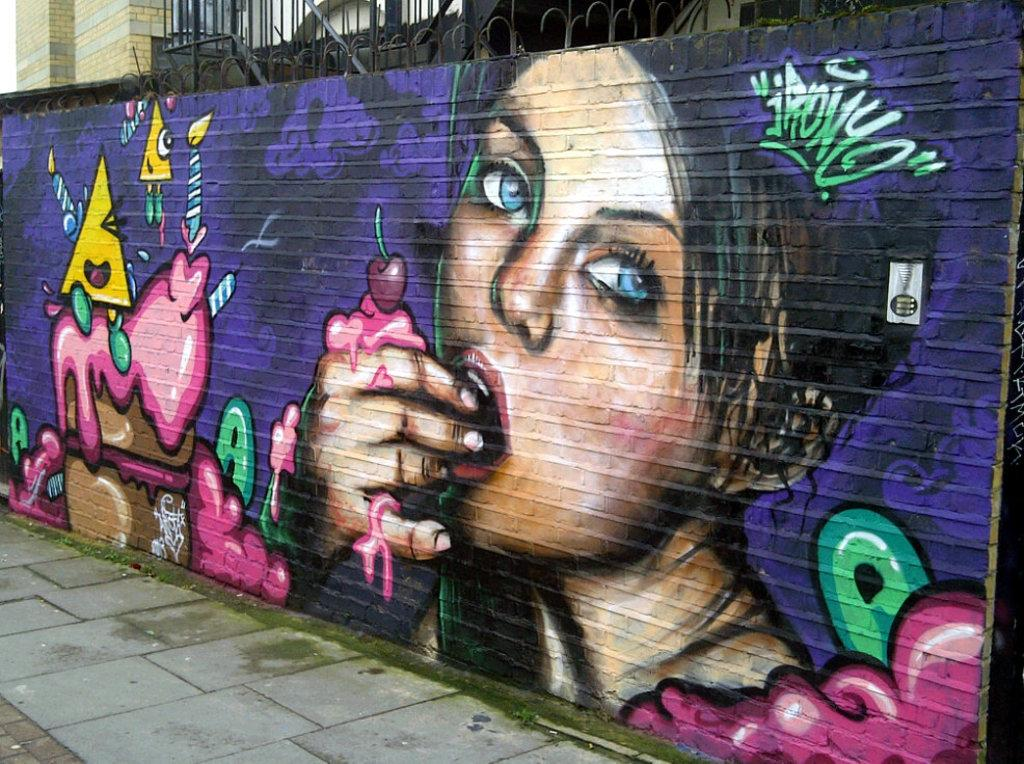What is located at the front of the image? There is a wall in the front of the image. What can be seen in the background of the image? There is a building in the background of the image. What is depicted on the wall in the image? There is graffiti of a person on the wall. How many ants can be seen crawling on the graffiti in the image? There are no ants present in the image; it features graffiti of a person on a wall. What direction is the snail moving on the wall in the image? There is no snail present in the image; it features graffiti of a person on a wall. 